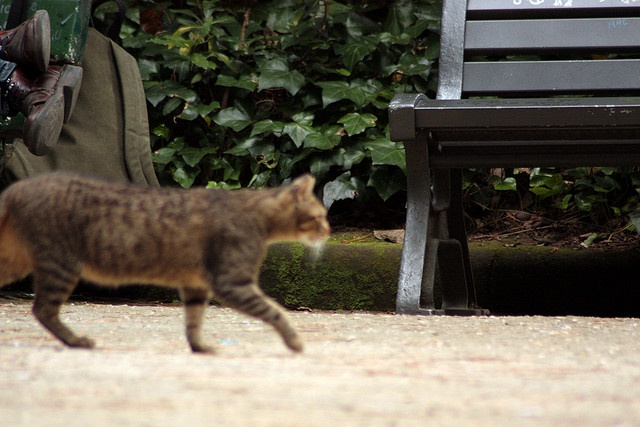Describe the objects in this image and their specific colors. I can see bench in darkblue, black, and gray tones, cat in darkblue, maroon, black, and gray tones, backpack in darkblue, gray, and black tones, and people in darkblue, black, and gray tones in this image. 